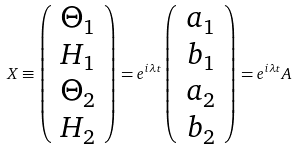Convert formula to latex. <formula><loc_0><loc_0><loc_500><loc_500>X \equiv \left ( \begin{array} { c } \Theta _ { 1 } \\ H _ { 1 } \\ \Theta _ { 2 } \\ H _ { 2 } \end{array} \right ) = e ^ { i \lambda t } \left ( \begin{array} { c } a _ { 1 } \\ b _ { 1 } \\ a _ { 2 } \\ b _ { 2 } \end{array} \right ) = e ^ { i \lambda t } A</formula> 